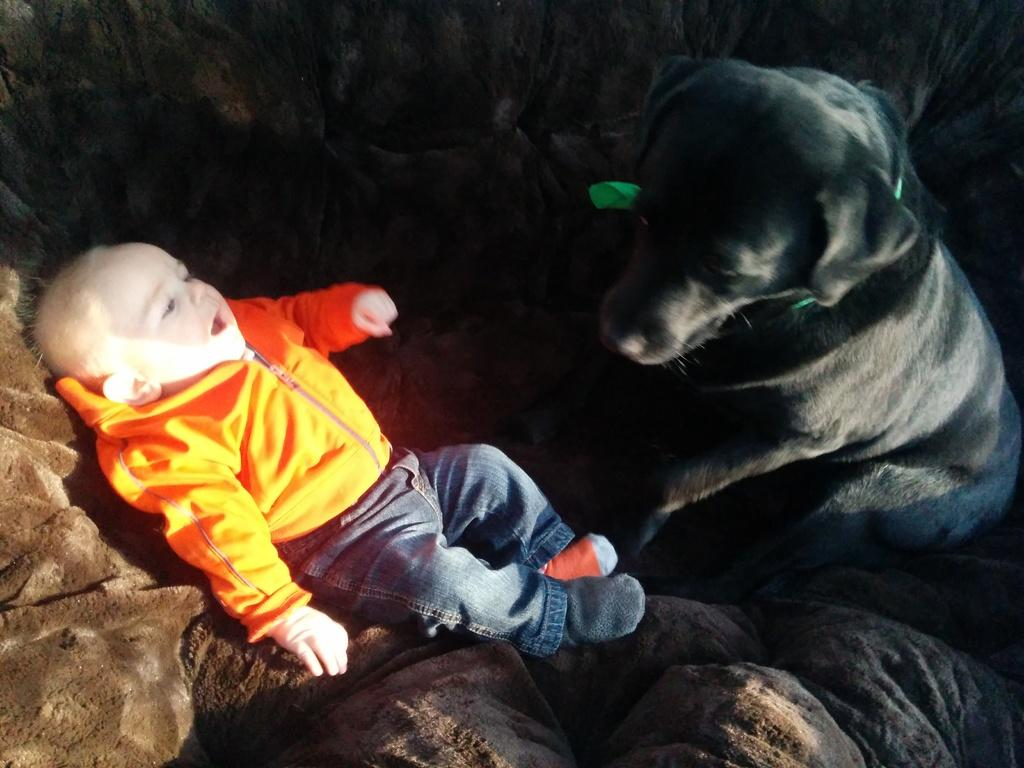Who is the main subject in the image? There is a boy in the image. What is the boy wearing? The boy is wearing a jacket and socks on his feet. What is the boy doing in the image? The boy is sleeping on the floor. Is there any animal present in the image? Yes, there is a black color dog beside the boy. What is the color of the background in the image? The background of the image is dark. What type of club can be seen in the boy's hand in the image? There is no club present in the image; the boy is sleeping and not holding any objects. 